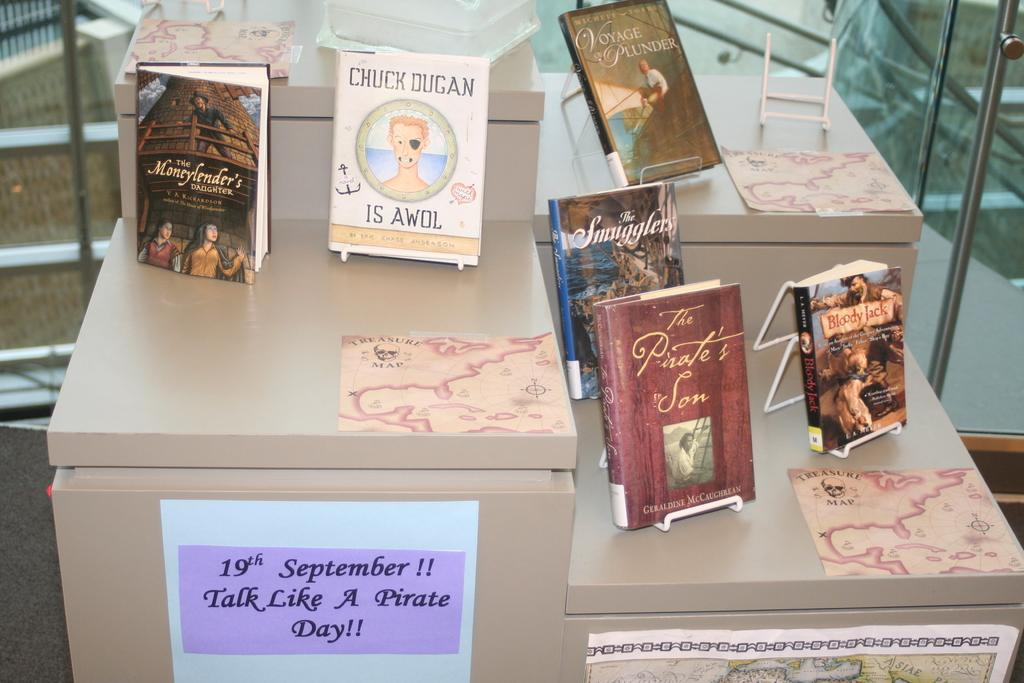<image>
Share a concise interpretation of the image provided. Pirate books are displayed to celebrate Talk Like a Pirate Day on September 19th. 